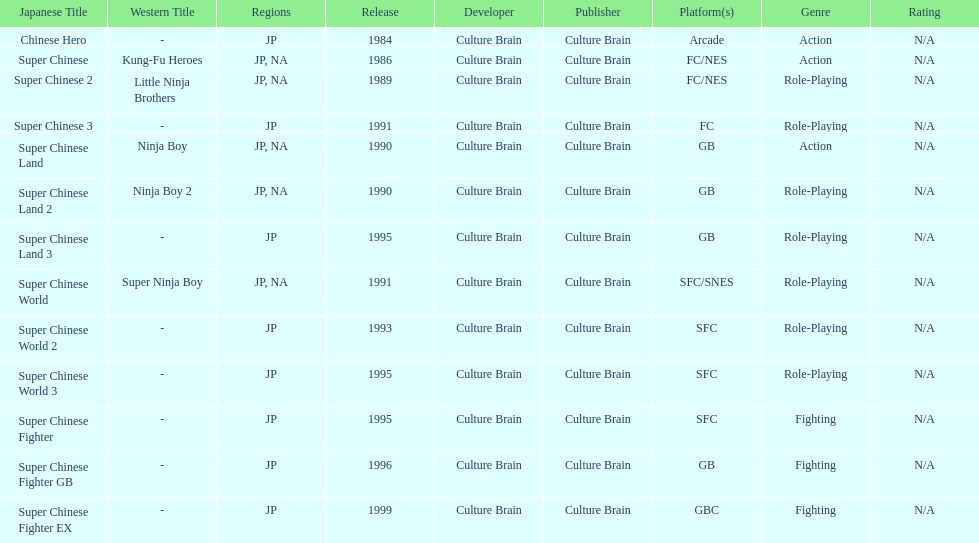Which platforms had the most titles released? GB. 